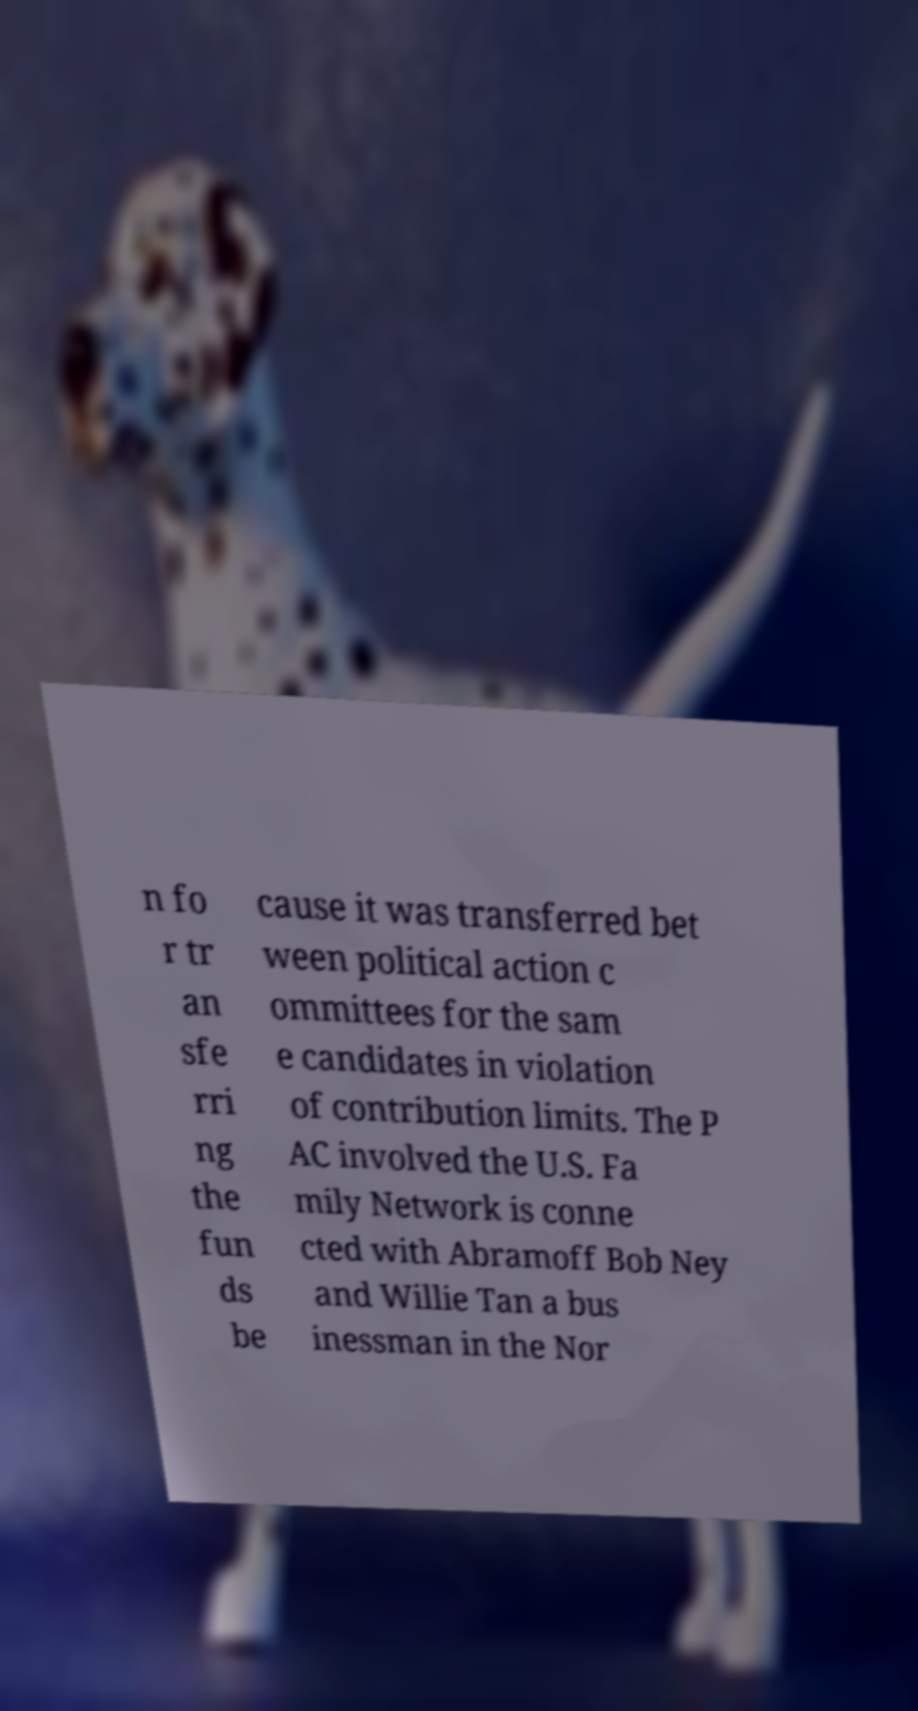Could you extract and type out the text from this image? n fo r tr an sfe rri ng the fun ds be cause it was transferred bet ween political action c ommittees for the sam e candidates in violation of contribution limits. The P AC involved the U.S. Fa mily Network is conne cted with Abramoff Bob Ney and Willie Tan a bus inessman in the Nor 